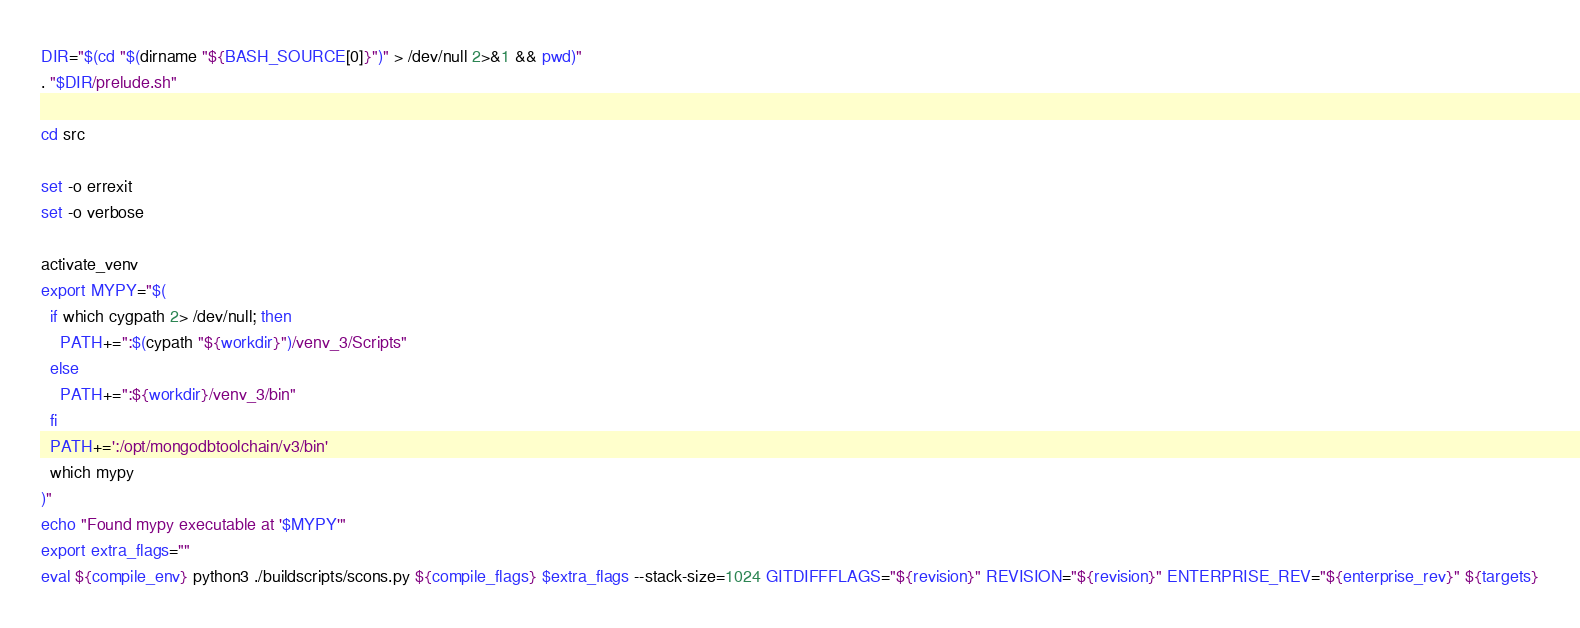<code> <loc_0><loc_0><loc_500><loc_500><_Bash_>DIR="$(cd "$(dirname "${BASH_SOURCE[0]}")" > /dev/null 2>&1 && pwd)"
. "$DIR/prelude.sh"

cd src

set -o errexit
set -o verbose

activate_venv
export MYPY="$(
  if which cygpath 2> /dev/null; then
    PATH+=":$(cypath "${workdir}")/venv_3/Scripts"
  else
    PATH+=":${workdir}/venv_3/bin"
  fi
  PATH+=':/opt/mongodbtoolchain/v3/bin'
  which mypy
)"
echo "Found mypy executable at '$MYPY'"
export extra_flags=""
eval ${compile_env} python3 ./buildscripts/scons.py ${compile_flags} $extra_flags --stack-size=1024 GITDIFFFLAGS="${revision}" REVISION="${revision}" ENTERPRISE_REV="${enterprise_rev}" ${targets}
</code> 